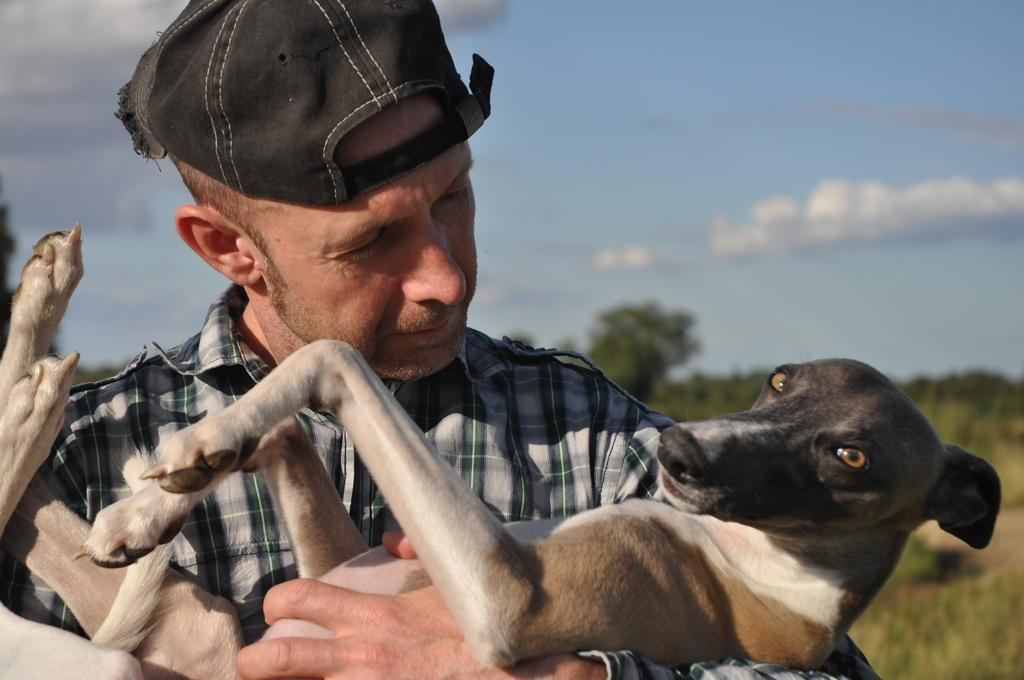Who is present in the image? There is a man in the image. What is the man wearing on his head? The man is wearing a black hat. What is the man holding in the image? The man is holding a dog. What can be seen in the background of the image? There are trees in the background of the image. What is visible at the top of the image? The sky is visible at the top of the image. What type of silver object can be seen in the man's hand in the image? There is no silver object present in the man's hand in the image; he is holding a dog. What type of bushes can be seen in the background of the image? There is no mention of bushes in the background of the image; only trees are mentioned. 